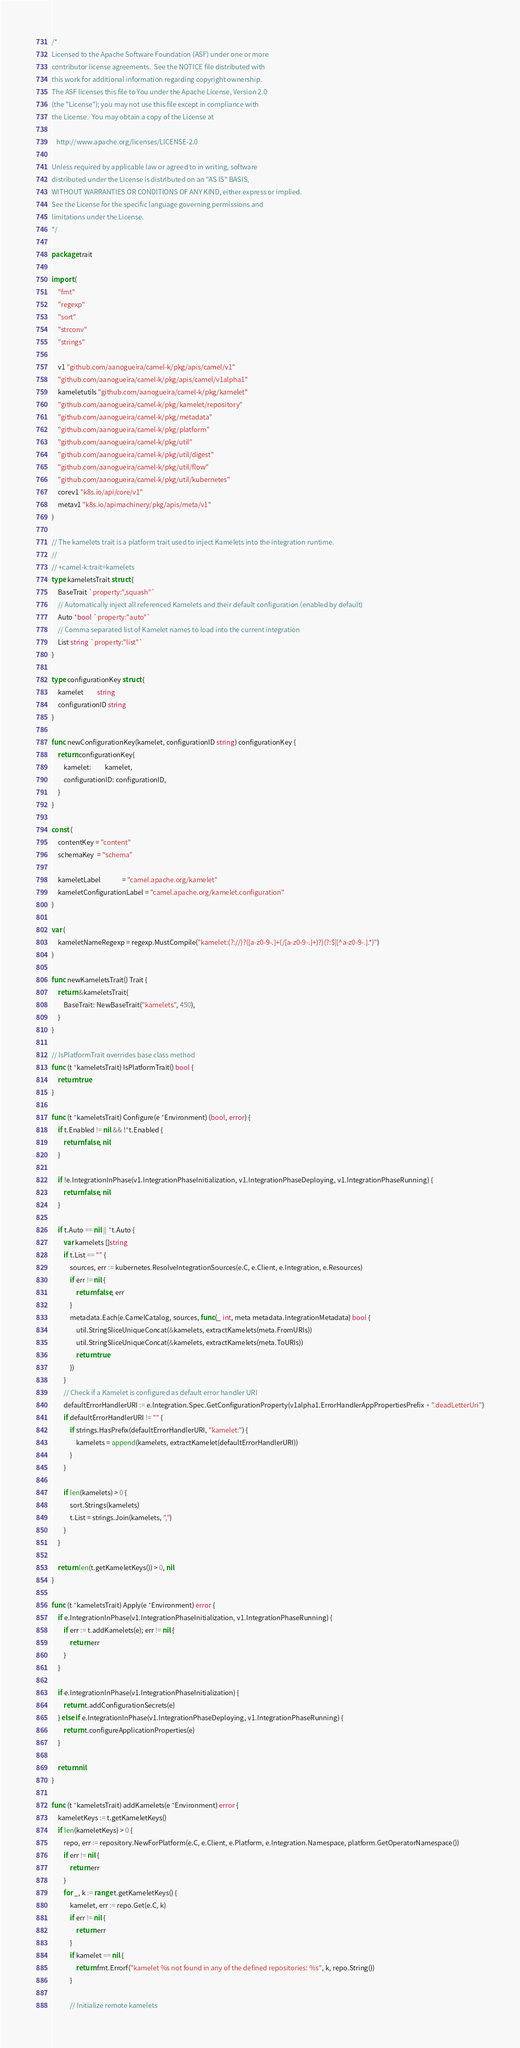Convert code to text. <code><loc_0><loc_0><loc_500><loc_500><_Go_>/*
Licensed to the Apache Software Foundation (ASF) under one or more
contributor license agreements.  See the NOTICE file distributed with
this work for additional information regarding copyright ownership.
The ASF licenses this file to You under the Apache License, Version 2.0
(the "License"); you may not use this file except in compliance with
the License.  You may obtain a copy of the License at

   http://www.apache.org/licenses/LICENSE-2.0

Unless required by applicable law or agreed to in writing, software
distributed under the License is distributed on an "AS IS" BASIS,
WITHOUT WARRANTIES OR CONDITIONS OF ANY KIND, either express or implied.
See the License for the specific language governing permissions and
limitations under the License.
*/

package trait

import (
	"fmt"
	"regexp"
	"sort"
	"strconv"
	"strings"

	v1 "github.com/aanogueira/camel-k/pkg/apis/camel/v1"
	"github.com/aanogueira/camel-k/pkg/apis/camel/v1alpha1"
	kameletutils "github.com/aanogueira/camel-k/pkg/kamelet"
	"github.com/aanogueira/camel-k/pkg/kamelet/repository"
	"github.com/aanogueira/camel-k/pkg/metadata"
	"github.com/aanogueira/camel-k/pkg/platform"
	"github.com/aanogueira/camel-k/pkg/util"
	"github.com/aanogueira/camel-k/pkg/util/digest"
	"github.com/aanogueira/camel-k/pkg/util/flow"
	"github.com/aanogueira/camel-k/pkg/util/kubernetes"
	corev1 "k8s.io/api/core/v1"
	metav1 "k8s.io/apimachinery/pkg/apis/meta/v1"
)

// The kamelets trait is a platform trait used to inject Kamelets into the integration runtime.
//
// +camel-k:trait=kamelets
type kameletsTrait struct {
	BaseTrait `property:",squash"`
	// Automatically inject all referenced Kamelets and their default configuration (enabled by default)
	Auto *bool `property:"auto"`
	// Comma separated list of Kamelet names to load into the current integration
	List string `property:"list"`
}

type configurationKey struct {
	kamelet         string
	configurationID string
}

func newConfigurationKey(kamelet, configurationID string) configurationKey {
	return configurationKey{
		kamelet:         kamelet,
		configurationID: configurationID,
	}
}

const (
	contentKey = "content"
	schemaKey  = "schema"

	kameletLabel              = "camel.apache.org/kamelet"
	kameletConfigurationLabel = "camel.apache.org/kamelet.configuration"
)

var (
	kameletNameRegexp = regexp.MustCompile("kamelet:(?://)?([a-z0-9-.]+(/[a-z0-9-.]+)?)(?:$|[^a-z0-9-.].*)")
)

func newKameletsTrait() Trait {
	return &kameletsTrait{
		BaseTrait: NewBaseTrait("kamelets", 450),
	}
}

// IsPlatformTrait overrides base class method
func (t *kameletsTrait) IsPlatformTrait() bool {
	return true
}

func (t *kameletsTrait) Configure(e *Environment) (bool, error) {
	if t.Enabled != nil && !*t.Enabled {
		return false, nil
	}

	if !e.IntegrationInPhase(v1.IntegrationPhaseInitialization, v1.IntegrationPhaseDeploying, v1.IntegrationPhaseRunning) {
		return false, nil
	}

	if t.Auto == nil || *t.Auto {
		var kamelets []string
		if t.List == "" {
			sources, err := kubernetes.ResolveIntegrationSources(e.C, e.Client, e.Integration, e.Resources)
			if err != nil {
				return false, err
			}
			metadata.Each(e.CamelCatalog, sources, func(_ int, meta metadata.IntegrationMetadata) bool {
				util.StringSliceUniqueConcat(&kamelets, extractKamelets(meta.FromURIs))
				util.StringSliceUniqueConcat(&kamelets, extractKamelets(meta.ToURIs))
				return true
			})
		}
		// Check if a Kamelet is configured as default error handler URI
		defaultErrorHandlerURI := e.Integration.Spec.GetConfigurationProperty(v1alpha1.ErrorHandlerAppPropertiesPrefix + ".deadLetterUri")
		if defaultErrorHandlerURI != "" {
			if strings.HasPrefix(defaultErrorHandlerURI, "kamelet:") {
				kamelets = append(kamelets, extractKamelet(defaultErrorHandlerURI))
			}
		}

		if len(kamelets) > 0 {
			sort.Strings(kamelets)
			t.List = strings.Join(kamelets, ",")
		}
	}

	return len(t.getKameletKeys()) > 0, nil
}

func (t *kameletsTrait) Apply(e *Environment) error {
	if e.IntegrationInPhase(v1.IntegrationPhaseInitialization, v1.IntegrationPhaseRunning) {
		if err := t.addKamelets(e); err != nil {
			return err
		}
	}

	if e.IntegrationInPhase(v1.IntegrationPhaseInitialization) {
		return t.addConfigurationSecrets(e)
	} else if e.IntegrationInPhase(v1.IntegrationPhaseDeploying, v1.IntegrationPhaseRunning) {
		return t.configureApplicationProperties(e)
	}

	return nil
}

func (t *kameletsTrait) addKamelets(e *Environment) error {
	kameletKeys := t.getKameletKeys()
	if len(kameletKeys) > 0 {
		repo, err := repository.NewForPlatform(e.C, e.Client, e.Platform, e.Integration.Namespace, platform.GetOperatorNamespace())
		if err != nil {
			return err
		}
		for _, k := range t.getKameletKeys() {
			kamelet, err := repo.Get(e.C, k)
			if err != nil {
				return err
			}
			if kamelet == nil {
				return fmt.Errorf("kamelet %s not found in any of the defined repositories: %s", k, repo.String())
			}

			// Initialize remote kamelets</code> 